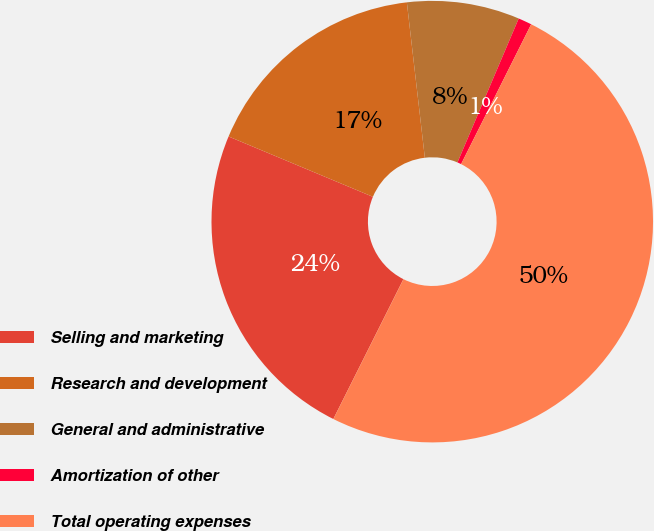Convert chart. <chart><loc_0><loc_0><loc_500><loc_500><pie_chart><fcel>Selling and marketing<fcel>Research and development<fcel>General and administrative<fcel>Amortization of other<fcel>Total operating expenses<nl><fcel>23.91%<fcel>16.86%<fcel>8.24%<fcel>0.99%<fcel>50.0%<nl></chart> 